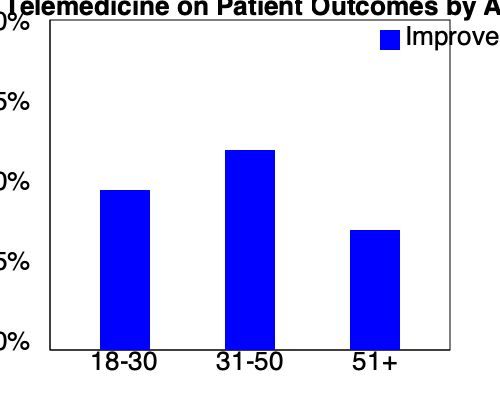Based on the chart showing the impact of telemedicine on patient outcomes across different age groups, which age group demonstrates the highest percentage of improved outcomes? How does this data challenge or support the skepticism about new health policies? To answer this question, we need to analyze the grouped column chart and interpret the data:

1. The chart shows three age groups: 18-30, 31-50, and 51+.
2. The y-axis represents the percentage of improved outcomes, ranging from 0% to 100%.
3. Each blue bar represents the percentage of improved outcomes for a specific age group.

Let's examine each age group:

1. 18-30 age group: The bar reaches approximately 50% on the y-axis.
2. 31-50 age group: The bar reaches approximately 60% on the y-axis.
3. 51+ age group: The bar reaches approximately 35% on the y-axis.

The 31-50 age group has the tallest bar, indicating the highest percentage of improved outcomes due to telemedicine.

This data challenges skepticism about new health policies in several ways:

1. It shows that telemedicine has a positive impact on patient outcomes across all age groups.
2. The 31-50 age group, which often includes working adults who may have difficulty attending in-person appointments, benefits the most from telemedicine.
3. Even the 51+ age group, which might be expected to struggle with technology, shows improved outcomes, albeit to a lesser extent.

However, the data also reveals areas for improvement:

1. The 51+ age group has the lowest percentage of improved outcomes, suggesting that additional support or tailored approaches may be needed for older patients.
2. None of the age groups reach 100% improved outcomes, indicating that there is still room for enhancement in telemedicine practices.
Answer: 31-50 age group; data shows positive impact of telemedicine across all ages, challenging skepticism while highlighting areas for improvement. 